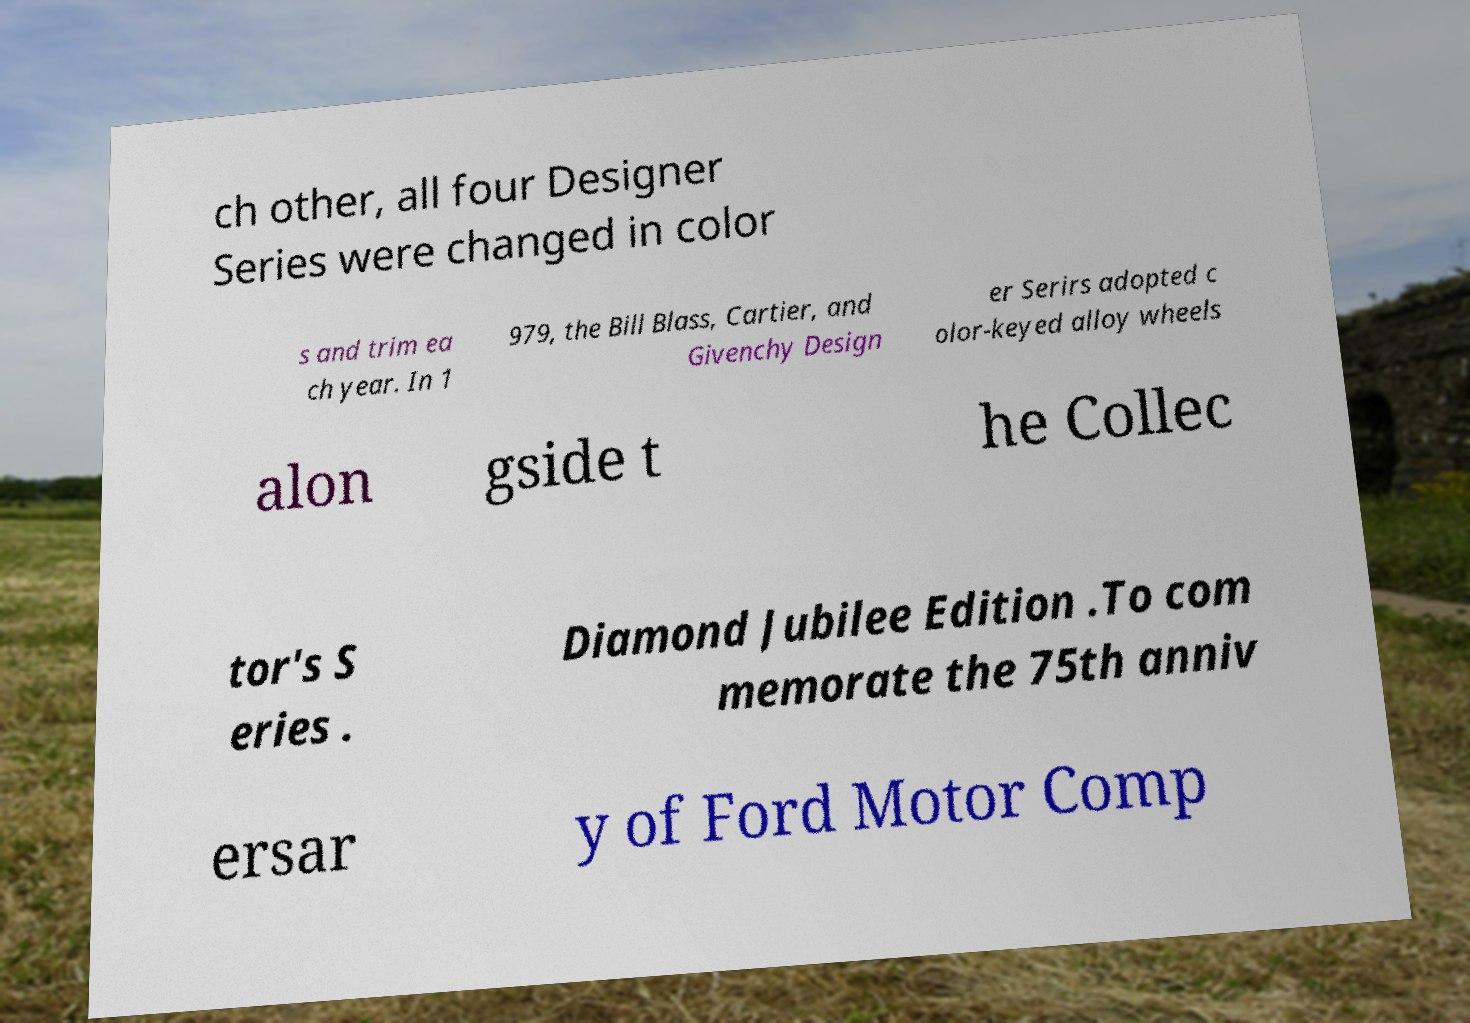Can you accurately transcribe the text from the provided image for me? ch other, all four Designer Series were changed in color s and trim ea ch year. In 1 979, the Bill Blass, Cartier, and Givenchy Design er Serirs adopted c olor-keyed alloy wheels alon gside t he Collec tor's S eries . Diamond Jubilee Edition .To com memorate the 75th anniv ersar y of Ford Motor Comp 